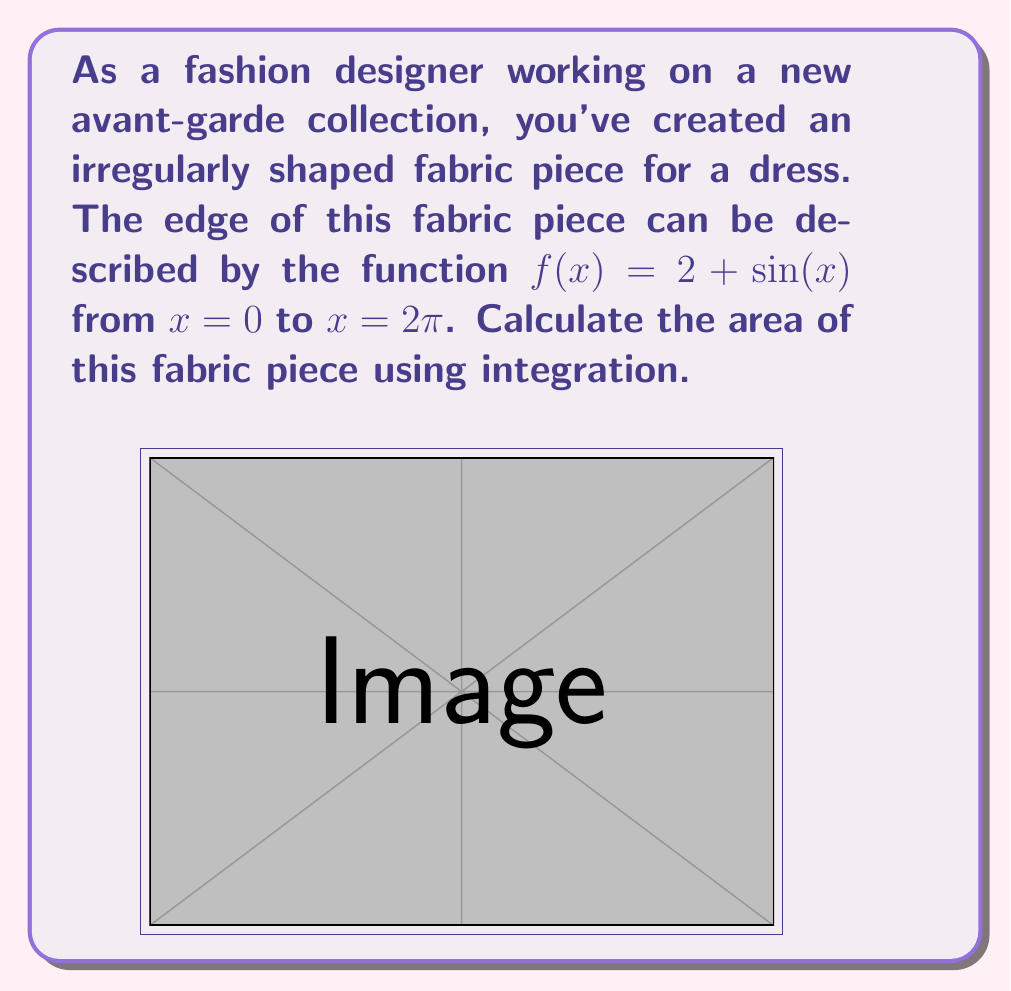Give your solution to this math problem. To find the area of this irregularly shaped fabric piece, we need to integrate the function $f(x) = 2 + \sin(x)$ from $x = 0$ to $x = 2\pi$. Here's how we can do this step-by-step:

1) The area is given by the definite integral:

   $$A = \int_0^{2\pi} (2 + \sin(x)) dx$$

2) Let's split this into two integrals:

   $$A = \int_0^{2\pi} 2 dx + \int_0^{2\pi} \sin(x) dx$$

3) For the first integral:
   
   $$\int_0^{2\pi} 2 dx = 2x \Big|_0^{2\pi} = 2(2\pi) - 2(0) = 4\pi$$

4) For the second integral:
   
   $$\int_0^{2\pi} \sin(x) dx = -\cos(x) \Big|_0^{2\pi} = -\cos(2\pi) + \cos(0) = -1 + 1 = 0$$

5) Adding the results from steps 3 and 4:

   $$A = 4\pi + 0 = 4\pi$$

Therefore, the area of the fabric piece is $4\pi$ square units.
Answer: $4\pi$ square units 